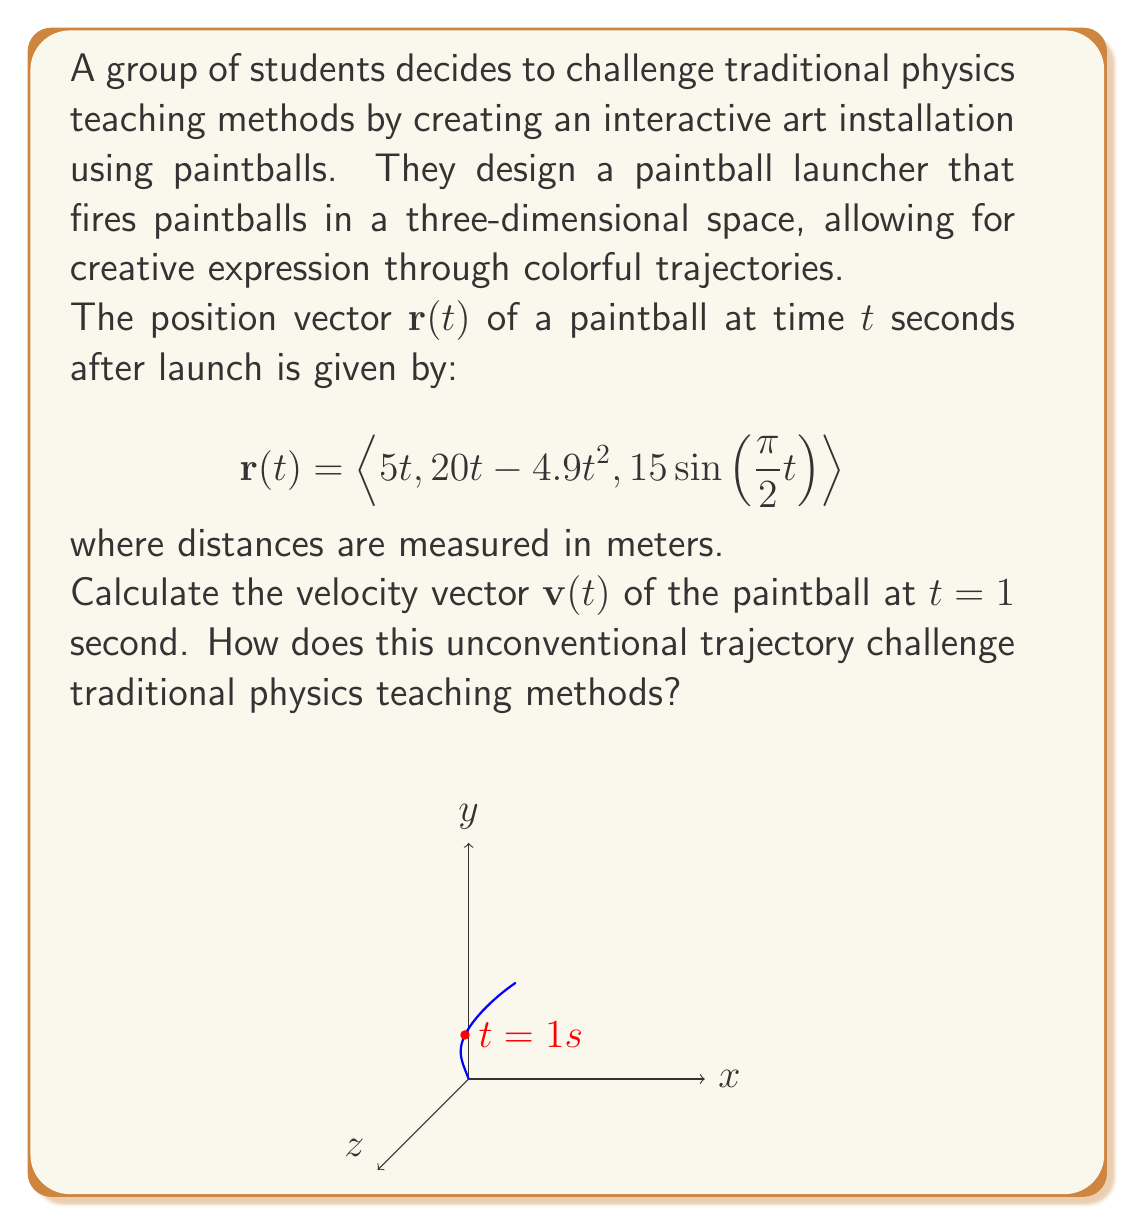Could you help me with this problem? To solve this problem and understand how it challenges traditional physics teaching methods, let's follow these steps:

1) The velocity vector $\mathbf{v}(t)$ is the derivative of the position vector $\mathbf{r}(t)$ with respect to time:

   $$\mathbf{v}(t) = \frac{d}{dt}\mathbf{r}(t)$$

2) Let's differentiate each component of $\mathbf{r}(t)$:

   $\frac{d}{dt}(5t) = 5$
   $\frac{d}{dt}(20t - 4.9t^2) = 20 - 9.8t$
   $\frac{d}{dt}(15\sin(\frac{\pi}{2}t)) = 15 \cdot \frac{\pi}{2} \cos(\frac{\pi}{2}t)$

3) Therefore, the velocity vector is:

   $$\mathbf{v}(t) = \langle 5, 20 - 9.8t, \frac{15\pi}{2} \cos(\frac{\pi}{2}t) \rangle$$

4) At $t = 1$ second:

   $$\mathbf{v}(1) = \langle 5, 20 - 9.8, \frac{15\pi}{2} \cos(\frac{\pi}{2}) \rangle = \langle 5, 10.2, 0 \rangle$$

This problem challenges traditional physics teaching methods in several ways:

1) It incorporates art and creativity into physics, making it more engaging for students who might not typically be interested in physics.

2) The trajectory is not a simple parabola as in many textbook problems. The z-component follows a sinusoidal path, introducing more complex motion analysis.

3) It encourages students to think about physics in a real-world, three-dimensional context rather than simplified 2D scenarios.

4) The problem promotes interdisciplinary thinking by combining physics, mathematics, and art.

5) It demonstrates that physics can be used to create aesthetic experiences, not just solve abstract problems.

This approach aligns with the persona's belief that strict school policies can limit creativity and self-expression, as it shows how physics can be taught in a more open-ended and expressive manner.
Answer: $\langle 5, 10.2, 0 \rangle$ m/s 